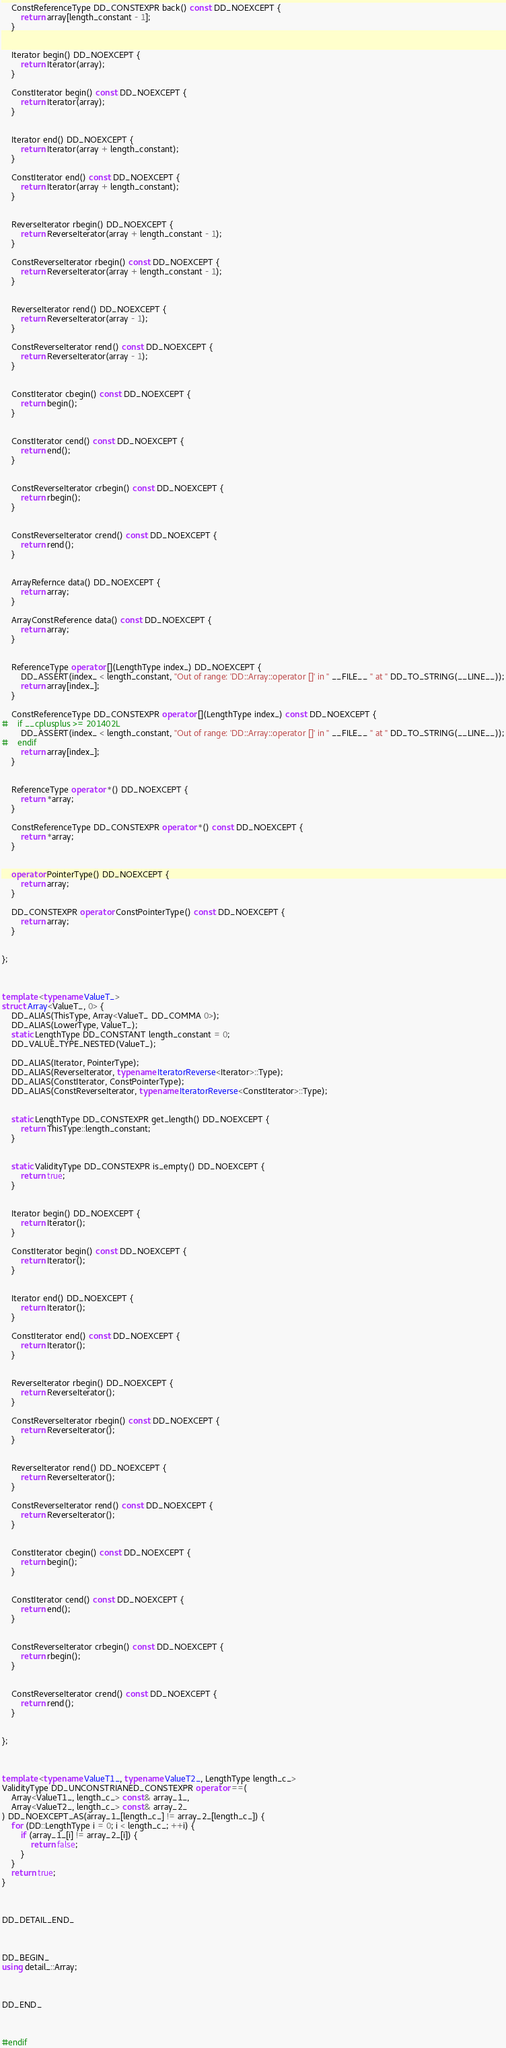<code> <loc_0><loc_0><loc_500><loc_500><_C++_>
	ConstReferenceType DD_CONSTEXPR back() const DD_NOEXCEPT {
		return array[length_constant - 1];
	}


	Iterator begin() DD_NOEXCEPT {
		return Iterator(array);
	}

	ConstIterator begin() const DD_NOEXCEPT {
		return Iterator(array);
	}


	Iterator end() DD_NOEXCEPT {
		return Iterator(array + length_constant);
	}

	ConstIterator end() const DD_NOEXCEPT {
		return Iterator(array + length_constant);
	}


	ReverseIterator rbegin() DD_NOEXCEPT {
		return ReverseIterator(array + length_constant - 1);
	}

	ConstReverseIterator rbegin() const DD_NOEXCEPT {
		return ReverseIterator(array + length_constant - 1);
	}


	ReverseIterator rend() DD_NOEXCEPT {
		return ReverseIterator(array - 1);
	}

	ConstReverseIterator rend() const DD_NOEXCEPT {
		return ReverseIterator(array - 1);
	}


	ConstIterator cbegin() const DD_NOEXCEPT {
		return begin();
	}


	ConstIterator cend() const DD_NOEXCEPT {
		return end();
	}


	ConstReverseIterator crbegin() const DD_NOEXCEPT {
		return rbegin();
	}


	ConstReverseIterator crend() const DD_NOEXCEPT {
		return rend();
	}


	ArrayRefernce data() DD_NOEXCEPT {
		return array;
	}

	ArrayConstReference data() const DD_NOEXCEPT {
		return array;
	}


	ReferenceType operator [](LengthType index_) DD_NOEXCEPT {
		DD_ASSERT(index_ < length_constant, "Out of range: 'DD::Array::operator []' in " __FILE__ " at " DD_TO_STRING(__LINE__));
		return array[index_];
	}

	ConstReferenceType DD_CONSTEXPR operator [](LengthType index_) const DD_NOEXCEPT {
#	if __cplusplus >= 201402L
		DD_ASSERT(index_ < length_constant, "Out of range: 'DD::Array::operator []' in " __FILE__ " at " DD_TO_STRING(__LINE__));
#	endif
		return array[index_];
	}


	ReferenceType operator *() DD_NOEXCEPT {
		return *array;
	}

	ConstReferenceType DD_CONSTEXPR operator *() const DD_NOEXCEPT {
		return *array;
	}


	operator PointerType() DD_NOEXCEPT {
		return array;
	}

	DD_CONSTEXPR operator ConstPointerType() const DD_NOEXCEPT {
		return array;
	}


};



template <typename ValueT_>
struct Array<ValueT_, 0> {
	DD_ALIAS(ThisType, Array<ValueT_ DD_COMMA 0>);
	DD_ALIAS(LowerType, ValueT_);
	static LengthType DD_CONSTANT length_constant = 0;
	DD_VALUE_TYPE_NESTED(ValueT_);

	DD_ALIAS(Iterator, PointerType);
	DD_ALIAS(ReverseIterator, typename IteratorReverse<Iterator>::Type);
	DD_ALIAS(ConstIterator, ConstPointerType);
	DD_ALIAS(ConstReverseIterator, typename IteratorReverse<ConstIterator>::Type);


	static LengthType DD_CONSTEXPR get_length() DD_NOEXCEPT {
		return ThisType::length_constant;
	}


	static ValidityType DD_CONSTEXPR is_empty() DD_NOEXCEPT {
		return true;
	}


	Iterator begin() DD_NOEXCEPT {
		return Iterator();
	}

	ConstIterator begin() const DD_NOEXCEPT {
		return Iterator();
	}


	Iterator end() DD_NOEXCEPT {
		return Iterator();
	}

	ConstIterator end() const DD_NOEXCEPT {
		return Iterator();
	}


	ReverseIterator rbegin() DD_NOEXCEPT {
		return ReverseIterator();
	}

	ConstReverseIterator rbegin() const DD_NOEXCEPT {
		return ReverseIterator();
	}


	ReverseIterator rend() DD_NOEXCEPT {
		return ReverseIterator();
	}

	ConstReverseIterator rend() const DD_NOEXCEPT {
		return ReverseIterator();
	}


	ConstIterator cbegin() const DD_NOEXCEPT {
		return begin();
	}


	ConstIterator cend() const DD_NOEXCEPT {
		return end();
	}


	ConstReverseIterator crbegin() const DD_NOEXCEPT {
		return rbegin();
	}


	ConstReverseIterator crend() const DD_NOEXCEPT {
		return rend();
	}


};



template <typename ValueT1_, typename ValueT2_, LengthType length_c_>
ValidityType DD_UNCONSTRIANED_CONSTEXPR operator ==(
	Array<ValueT1_, length_c_> const& array_1_,
	Array<ValueT2_, length_c_> const& array_2_
) DD_NOEXCEPT_AS(array_1_[length_c_] != array_2_[length_c_]) {
	for (DD::LengthType i = 0; i < length_c_; ++i) {
		if (array_1_[i] != array_2_[i]) {
			return false;
		}
	}
	return true;
}



DD_DETAIL_END_



DD_BEGIN_
using detail_::Array;



DD_END_



#endif
</code> 